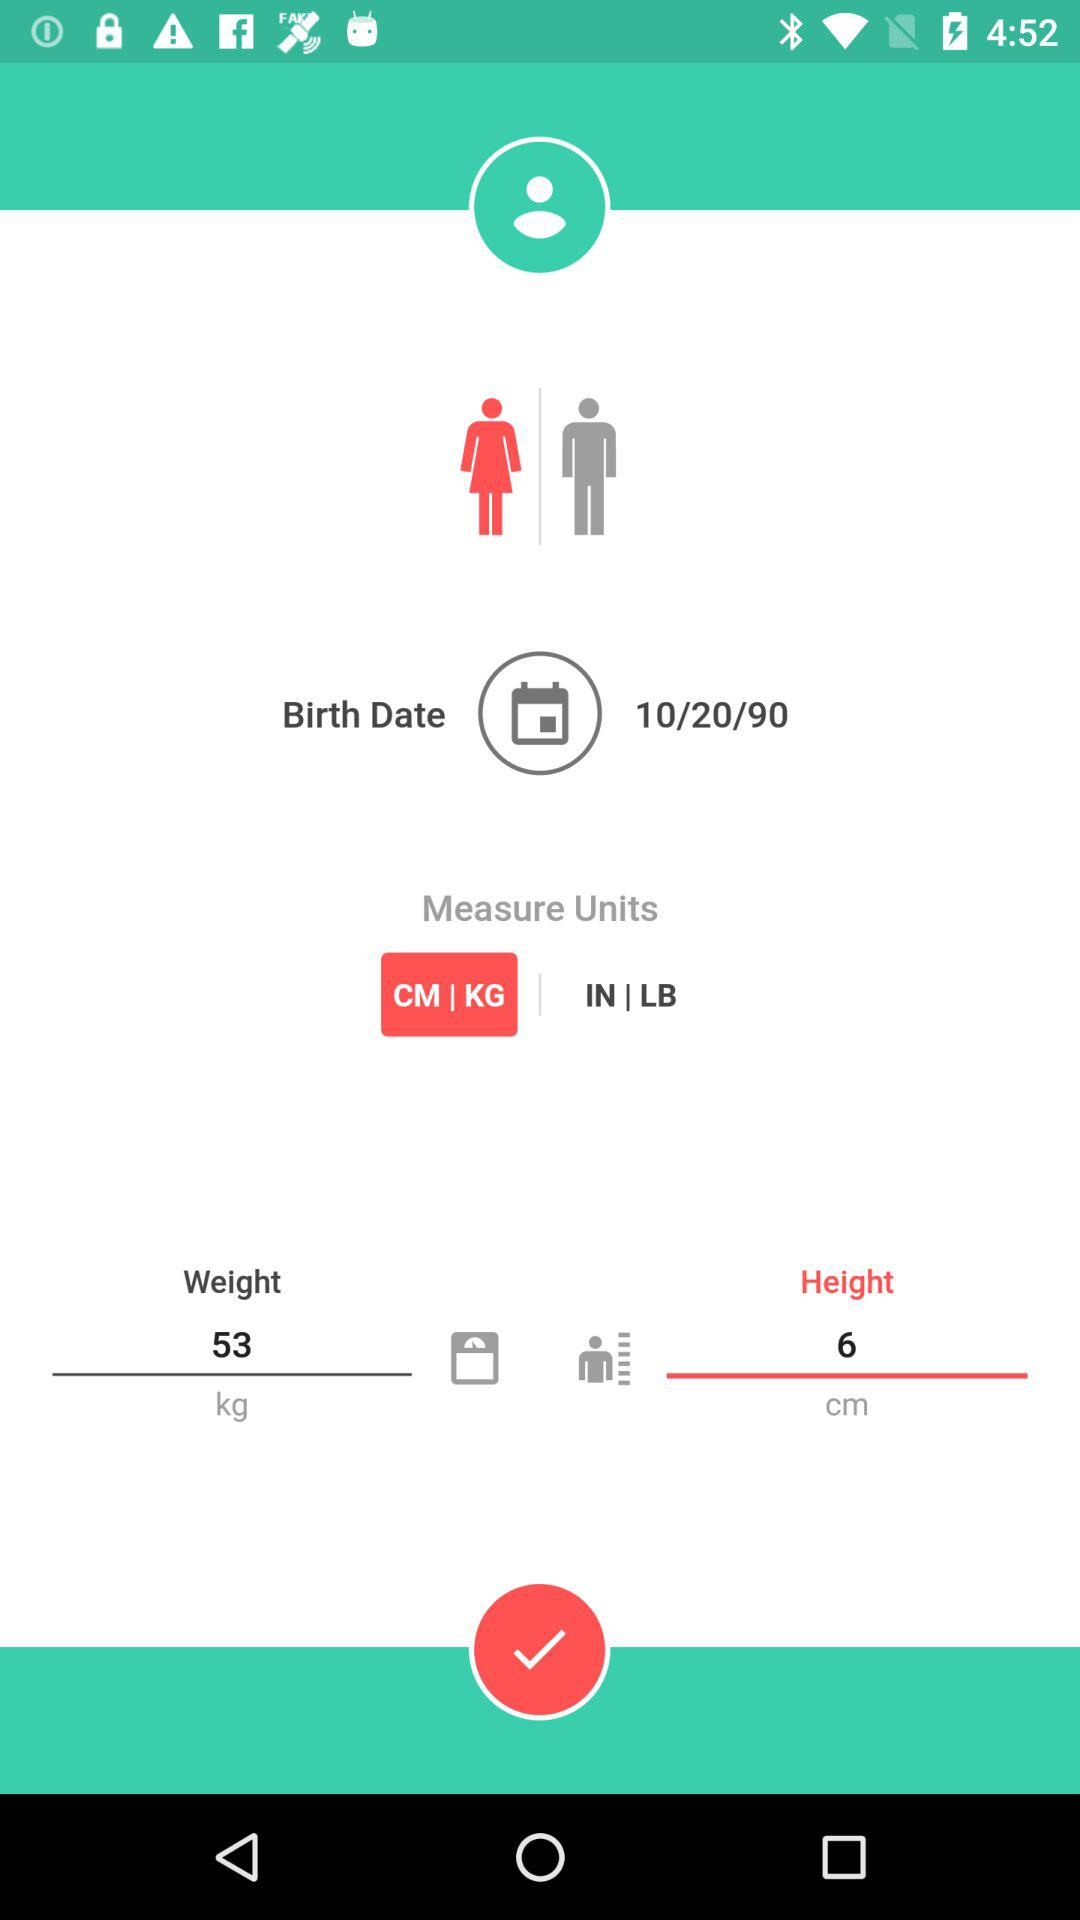What is the date of birth that is mentioned? The date of birth is 10/20/90. 